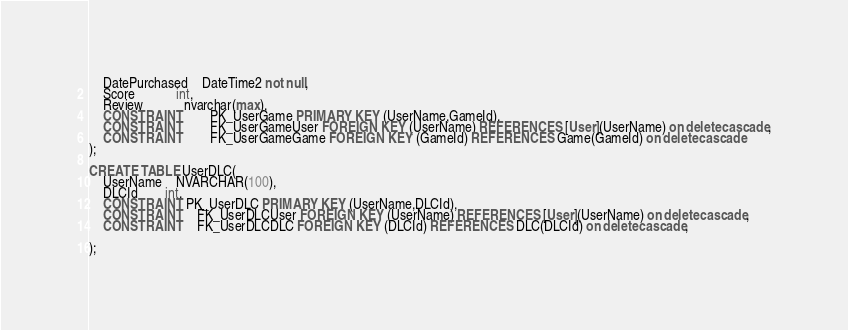Convert code to text. <code><loc_0><loc_0><loc_500><loc_500><_SQL_>	DatePurchased	DateTime2 not null,
	Score			int,
	Review			nvarchar(max),
	CONSTRAINT		PK_UserGame PRIMARY KEY (UserName,GameId),
	CONSTRAINT		FK_UserGameUser FOREIGN KEY (UserName) REFERENCES [User](UserName) on delete cascade,
	CONSTRAINT		FK_UserGameGame FOREIGN KEY (GameId) REFERENCES Game(GameId) on delete cascade
);

CREATE TABLE UserDLC(
	UserName	NVARCHAR(100),
	DLCId		int,
	CONSTRAINT PK_UserDLC PRIMARY KEY (UserName,DLCId),
	CONSTRAINT    FK_UserDLCUser FOREIGN KEY (UserName) REFERENCES [User](UserName) on delete cascade,
	CONSTRAINT    FK_UserDLCDLC FOREIGN KEY (DLCId) REFERENCES DLC(DLCId) on delete cascade,
	 
);
</code> 